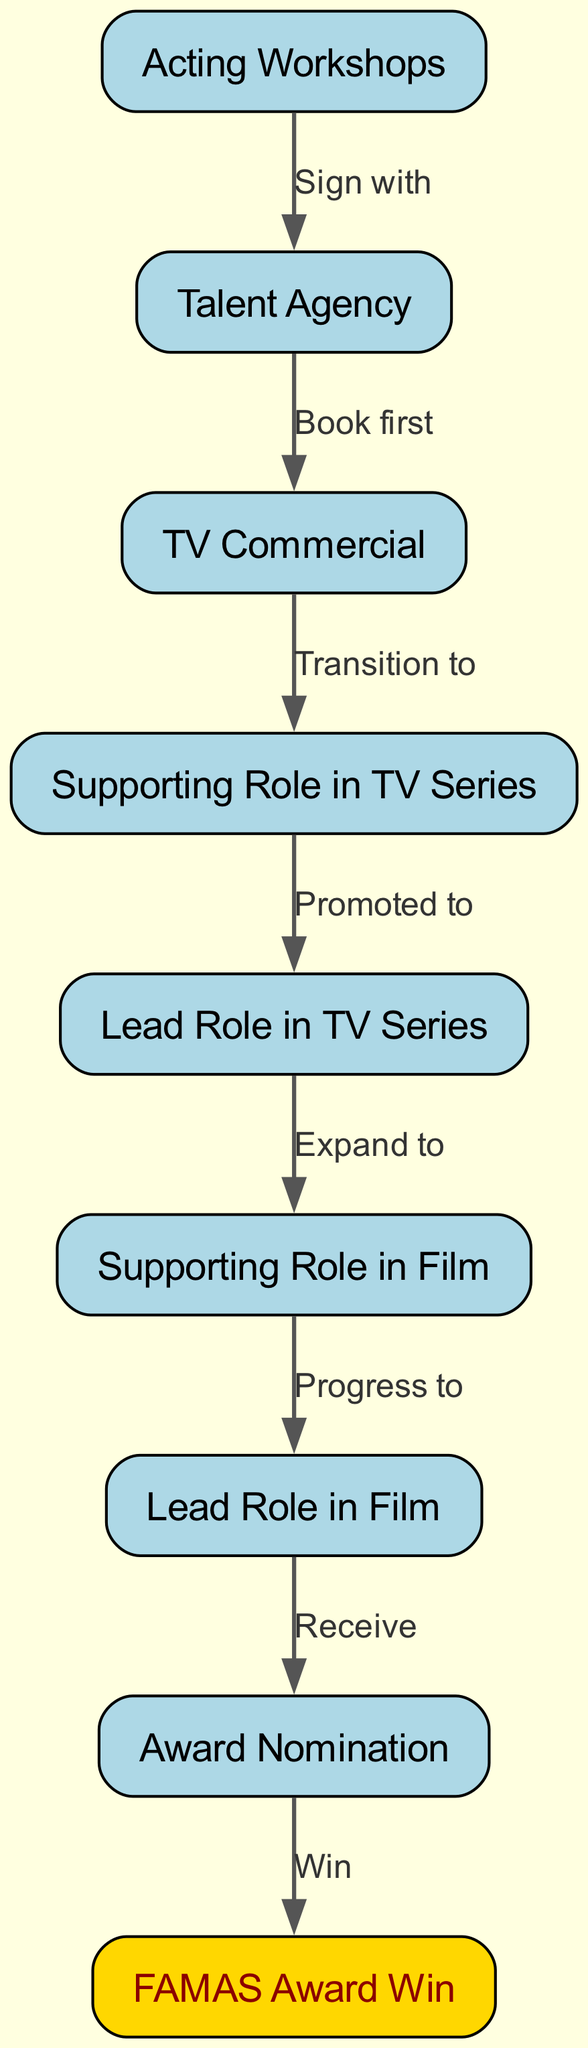What is the first step in the career progression? The first step is "Acting Workshops," as indicated by the starting node of the flowchart.
Answer: Acting Workshops How many nodes are present in the diagram? The total number of nodes is counted by identifying each unique label representing a stage or event in the career progression, which totals to 9 nodes.
Answer: 9 What do you transition to after a TV commercial? After a TV commercial, the next step in the progression is "Supporting Role in TV Series," as represented by the directed edge from the commercial to the supporting role node.
Answer: Supporting Role in TV Series What role comes after a supporting role in a film? After a supporting role in a film, the next progression is to "Lead Role in Film," as indicated by the flow from the film's supporting role to the lead role node.
Answer: Lead Role in Film What award is won after receiving an award nomination? The award won after receiving an award nomination is the "FAMAS Award Win," as shown in the flow from the nomination to the award win node.
Answer: FAMAS Award Win How many edges are in the diagram? The number of edges is determined by counting the connections between nodes, which totals 8 edges in the diagram.
Answer: 8 What is the last step in the career progression? The last step is "FAMAS Award Win," which is the final node in the flowchart representing the peak of this career progression.
Answer: FAMAS Award Win What do you expand to after a lead role in a TV series? After a lead role in a TV series, the next focus is on expanding to "Supporting Role in Film," as indicated by the directed flow from the lead role in the series to the film's supporting role.
Answer: Supporting Role in Film What is the significance of the gold color in the diagram? The gold color highlights the "FAMAS Award Win" node, signifying its importance as the ultimate achievement in the career progression pathway shown in the flowchart.
Answer: FAMAS Award Win 